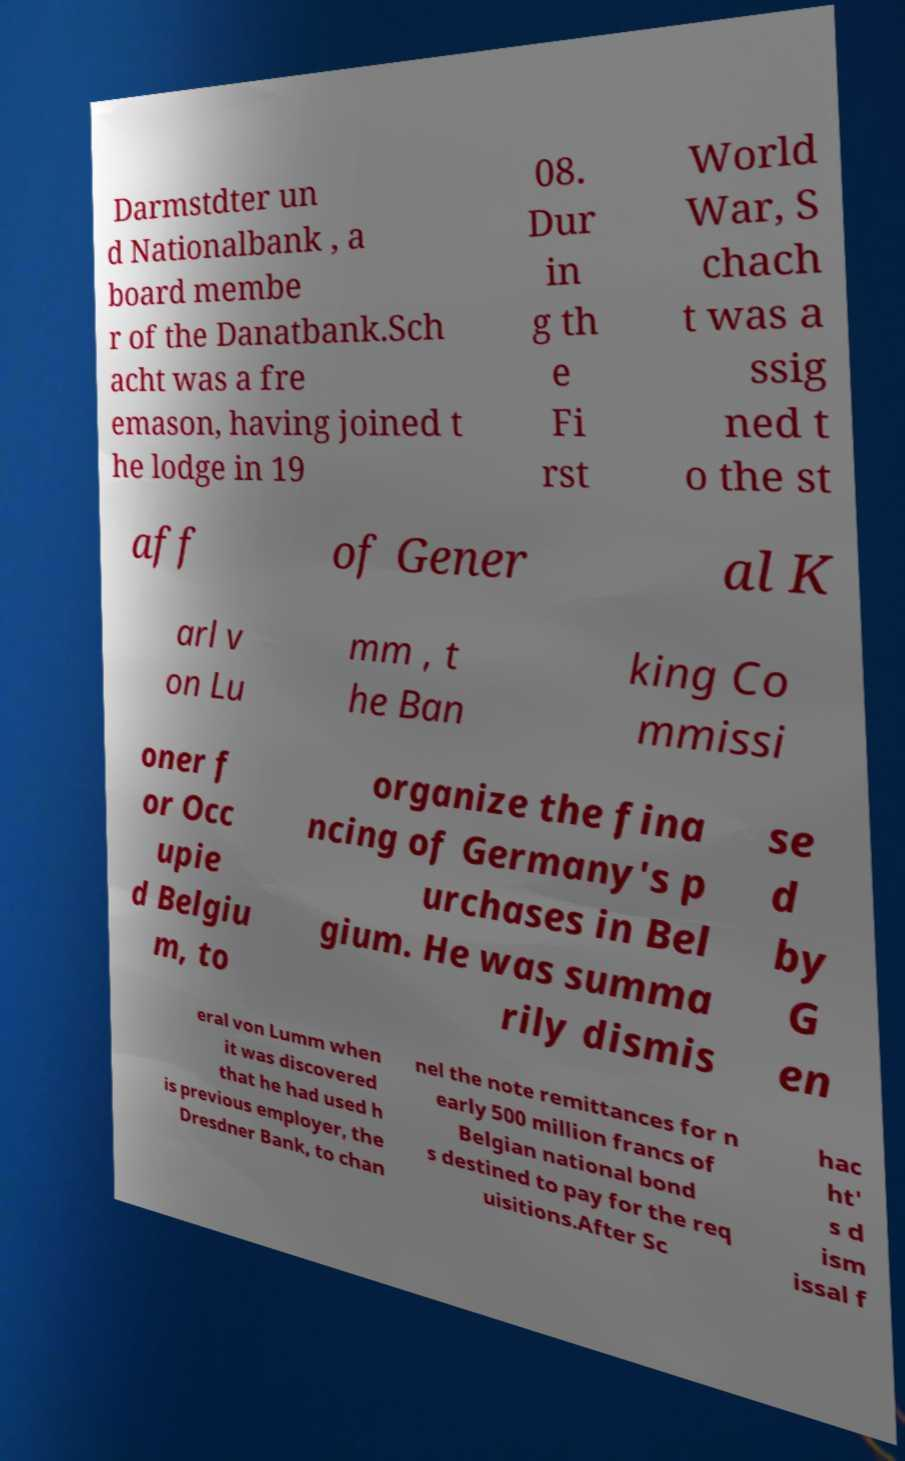I need the written content from this picture converted into text. Can you do that? Darmstdter un d Nationalbank , a board membe r of the Danatbank.Sch acht was a fre emason, having joined t he lodge in 19 08. Dur in g th e Fi rst World War, S chach t was a ssig ned t o the st aff of Gener al K arl v on Lu mm , t he Ban king Co mmissi oner f or Occ upie d Belgiu m, to organize the fina ncing of Germany's p urchases in Bel gium. He was summa rily dismis se d by G en eral von Lumm when it was discovered that he had used h is previous employer, the Dresdner Bank, to chan nel the note remittances for n early 500 million francs of Belgian national bond s destined to pay for the req uisitions.After Sc hac ht' s d ism issal f 